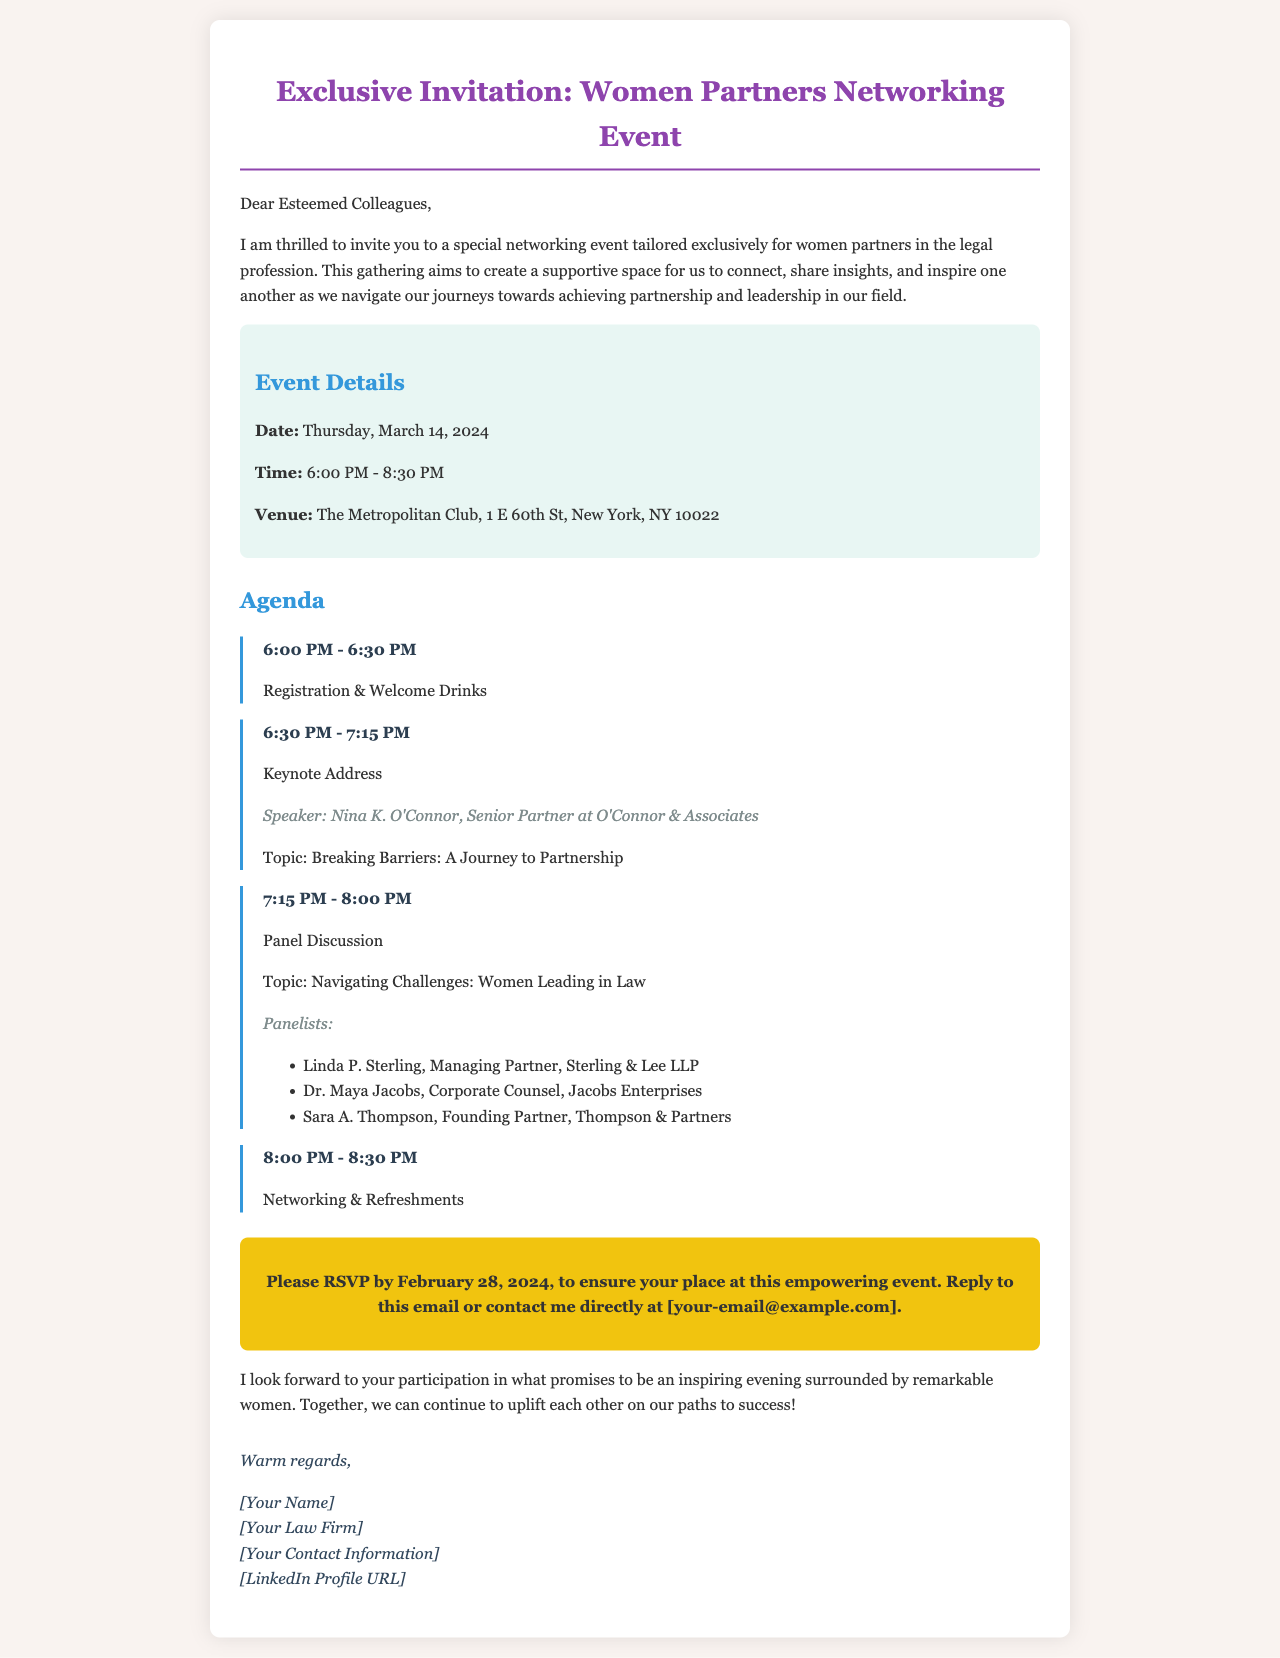What is the date of the event? The date of the event is specifically mentioned in the document as Thursday, March 14, 2024.
Answer: March 14, 2024 Who is the keynote speaker? The keynote speaker's name is provided in the agenda section as Nina K. O'Connor.
Answer: Nina K. O'Connor What is the location of the venue? The document provides the complete address of the venue for the event: The Metropolitan Club, 1 E 60th St, New York, NY 10022.
Answer: The Metropolitan Club, 1 E 60th St, New York, NY 10022 What is the topic of the keynote address? The topic of the keynote address is stated as "Breaking Barriers: A Journey to Partnership."
Answer: Breaking Barriers: A Journey to Partnership How long is the networking and refreshments period? The duration of the networking and refreshments period can be calculated by looking at the start and end times, which are from 8:00 PM to 8:30 PM, giving a length of 30 minutes.
Answer: 30 minutes What is the RSVP deadline? The RSVP deadline is explicitly mentioned in the call-to-action section as February 28, 2024.
Answer: February 28, 2024 Who are the panelists? The document lists three panelists, specifically named in the panel discussion section: Linda P. Sterling, Dr. Maya Jacobs, and Sara A. Thompson.
Answer: Linda P. Sterling, Dr. Maya Jacobs, Sara A. Thompson What is the purpose of the event? The purpose of the event is summarized in the introduction of the email, which is to create a supportive space for women partners to connect and inspire one another.
Answer: Connect and inspire one another 